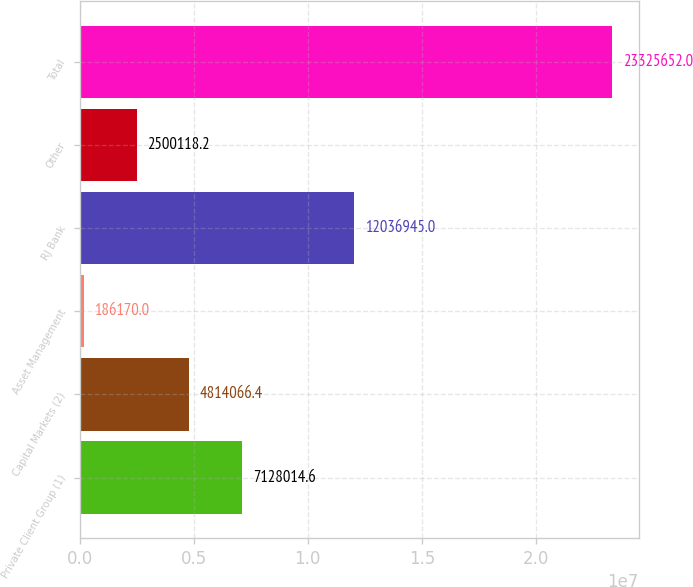<chart> <loc_0><loc_0><loc_500><loc_500><bar_chart><fcel>Private Client Group (1)<fcel>Capital Markets (2)<fcel>Asset Management<fcel>RJ Bank<fcel>Other<fcel>Total<nl><fcel>7.12801e+06<fcel>4.81407e+06<fcel>186170<fcel>1.20369e+07<fcel>2.50012e+06<fcel>2.33257e+07<nl></chart> 